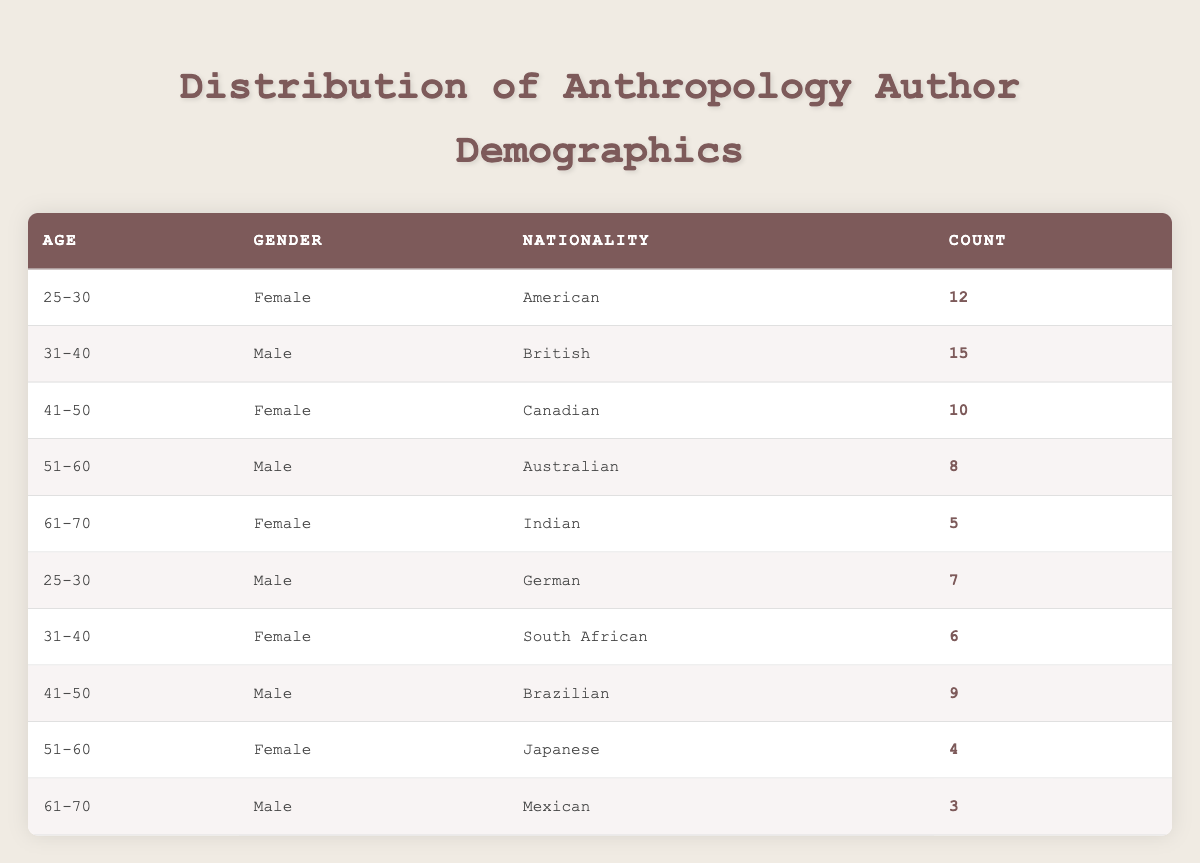What is the total number of female authors in the age group 25-30? The data shows there are 12 female authors aged 25-30. There are no other entries for this specific age group, so the total is 12.
Answer: 12 How many authors are aged 31-40? There are two entries for the age group 31-40: one male author from Britain (15) and one female author from South Africa (6). Adding these counts gives 15 + 6 = 21.
Answer: 21 Is there a male author from Japan in the table? The table lists a female author from Japan aged 51-60 and does not mention any male authors from Japan, hence the answer is no.
Answer: No Which nationality has the highest count of authors across all demographics? The British male author aged 31-40 has the highest individual count of 15. No other nationality exceeds this count when summed up across all entries. Thus, British authors have the highest count.
Answer: British What is the average number of authors per age group? There are 5 age groups (25-30, 31-40, 41-50, 51-60, 61-70). Summing the counts gives 12 + 15 + 10 + 8 + 5 + 7 + 6 + 9 + 4 + 3 = 69. Dividing this by the number of age groups (69/5) yields an average of 13.8.
Answer: 13.8 How many total authors are from North America? North American authors include the American (12) and Canadian (10) authors. Their total is 12 + 10 = 22.
Answer: 22 Are there more authors in the age range of 41-50 compared to 51-60? In the 41-50 age group, there are two authors: one female Canadian (10) and one male Brazilian (9), totaling 19. In the 51-60 age group, there are two authors: one male Australian (8) and one female Japanese (4), totaling 12. Since 19 is greater than 12, the statement is true.
Answer: Yes What is the combined count of authors aged 61-70? There are two entries for the age group 61-70: one female Indian author (5) and one male Mexican author (3). Adding these counts, we get 5 + 3 = 8.
Answer: 8 Which gender has a higher total count in the age group 51-60? There is one male author from Australia with a count of 8, and one female author from Japan with a count of 4. The male count (8) is higher than the female count (4) in this age group.
Answer: Male 